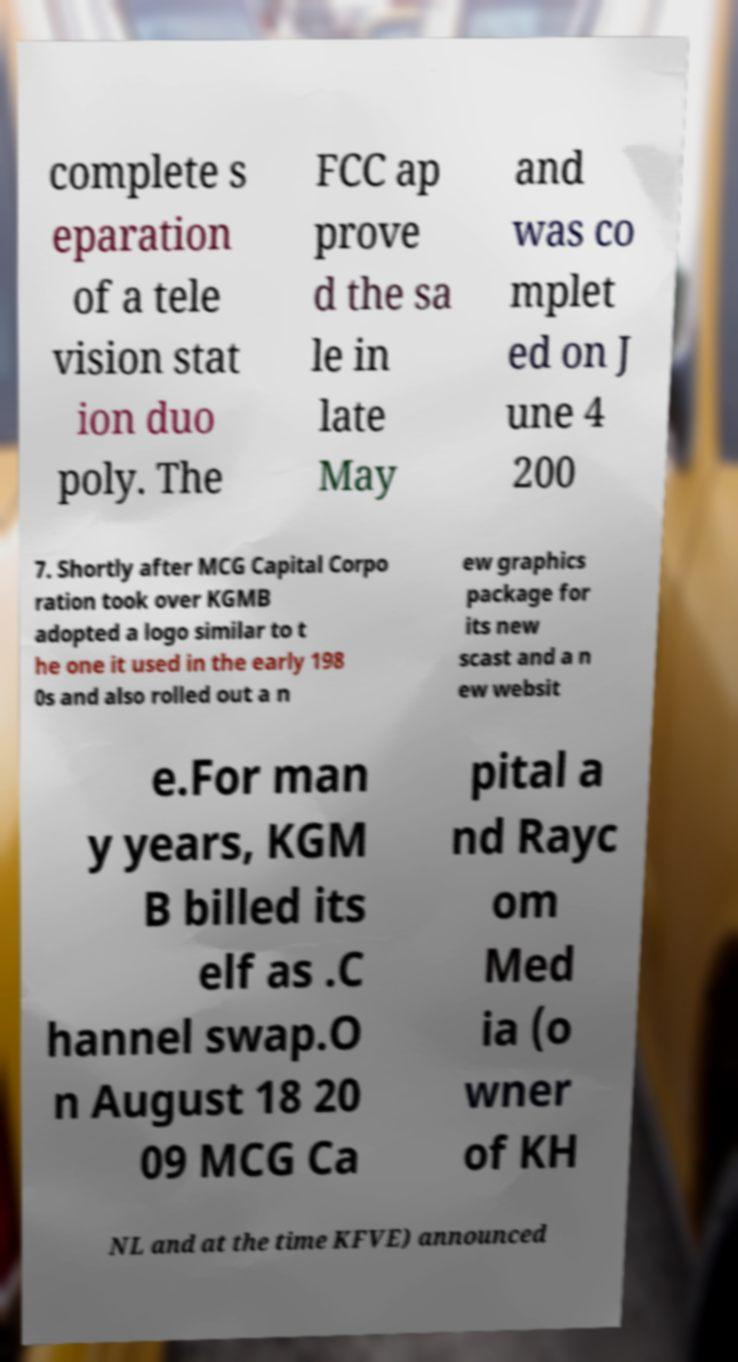There's text embedded in this image that I need extracted. Can you transcribe it verbatim? complete s eparation of a tele vision stat ion duo poly. The FCC ap prove d the sa le in late May and was co mplet ed on J une 4 200 7. Shortly after MCG Capital Corpo ration took over KGMB adopted a logo similar to t he one it used in the early 198 0s and also rolled out a n ew graphics package for its new scast and a n ew websit e.For man y years, KGM B billed its elf as .C hannel swap.O n August 18 20 09 MCG Ca pital a nd Rayc om Med ia (o wner of KH NL and at the time KFVE) announced 